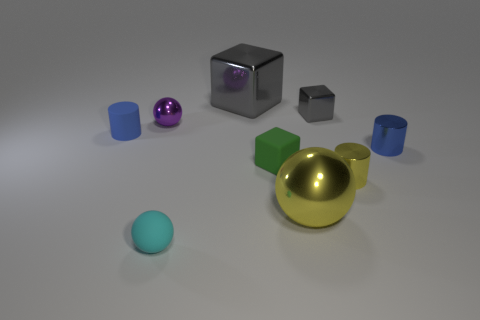Subtract all spheres. How many objects are left? 6 Subtract all small blue things. Subtract all small purple shiny things. How many objects are left? 6 Add 4 small shiny blocks. How many small shiny blocks are left? 5 Add 6 metal blocks. How many metal blocks exist? 8 Subtract 2 blue cylinders. How many objects are left? 7 